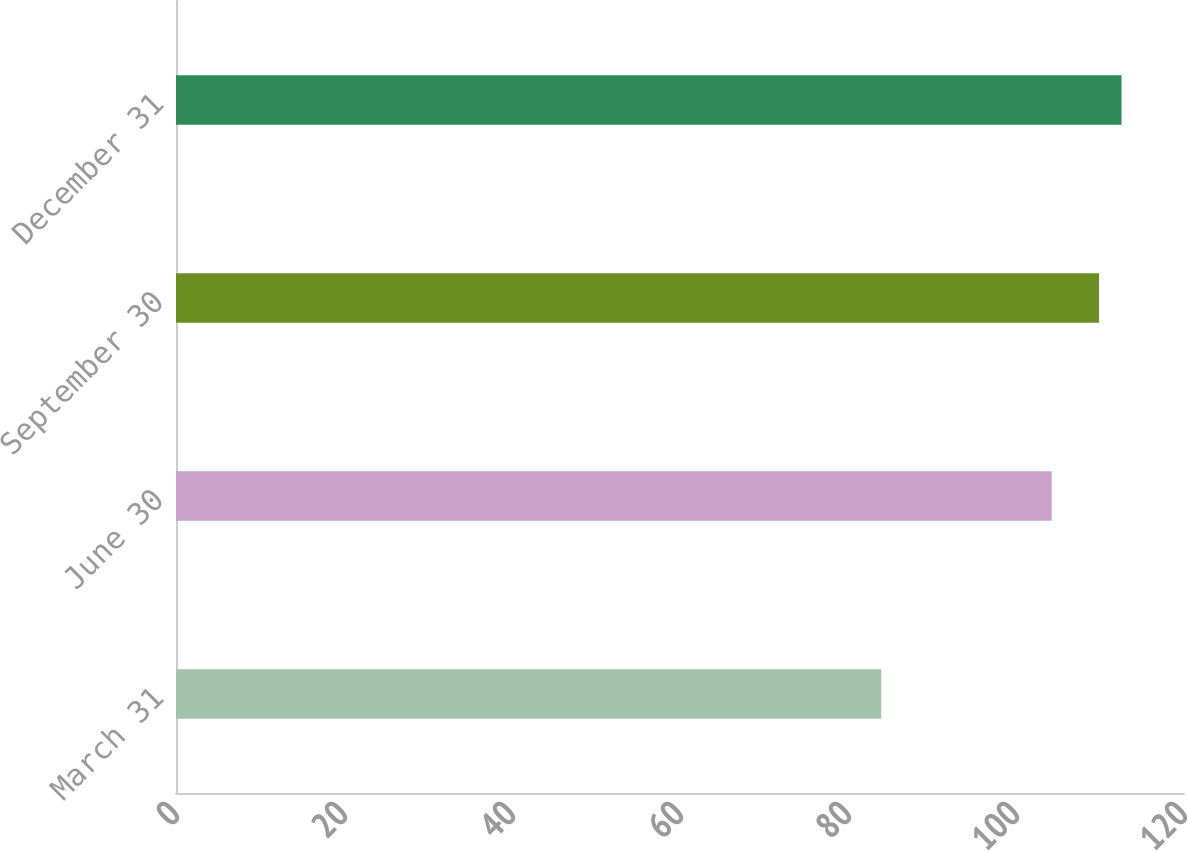Convert chart to OTSL. <chart><loc_0><loc_0><loc_500><loc_500><bar_chart><fcel>March 31<fcel>June 30<fcel>September 30<fcel>December 31<nl><fcel>83.96<fcel>104.25<fcel>109.88<fcel>112.56<nl></chart> 